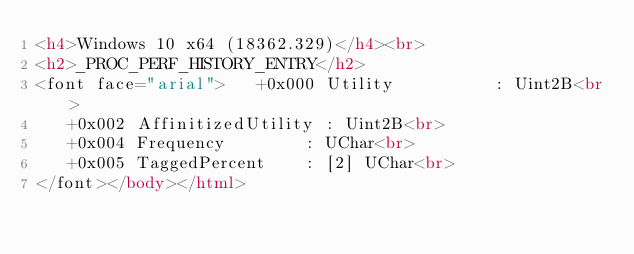Convert code to text. <code><loc_0><loc_0><loc_500><loc_500><_HTML_><h4>Windows 10 x64 (18362.329)</h4><br>
<h2>_PROC_PERF_HISTORY_ENTRY</h2>
<font face="arial">   +0x000 Utility          : Uint2B<br>
   +0x002 AffinitizedUtility : Uint2B<br>
   +0x004 Frequency        : UChar<br>
   +0x005 TaggedPercent    : [2] UChar<br>
</font></body></html></code> 